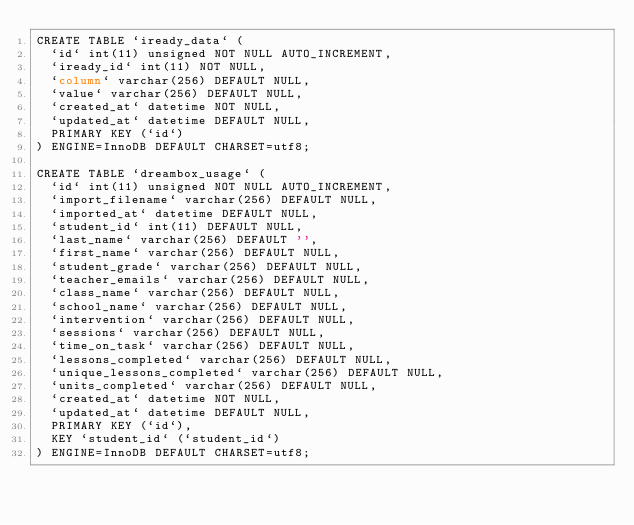Convert code to text. <code><loc_0><loc_0><loc_500><loc_500><_SQL_>CREATE TABLE `iready_data` (
  `id` int(11) unsigned NOT NULL AUTO_INCREMENT,
  `iready_id` int(11) NOT NULL,
  `column` varchar(256) DEFAULT NULL,
  `value` varchar(256) DEFAULT NULL,
  `created_at` datetime NOT NULL,
  `updated_at` datetime DEFAULT NULL,
  PRIMARY KEY (`id`)
) ENGINE=InnoDB DEFAULT CHARSET=utf8;

CREATE TABLE `dreambox_usage` (
  `id` int(11) unsigned NOT NULL AUTO_INCREMENT,
  `import_filename` varchar(256) DEFAULT NULL,
  `imported_at` datetime DEFAULT NULL,
  `student_id` int(11) DEFAULT NULL,
  `last_name` varchar(256) DEFAULT '',
  `first_name` varchar(256) DEFAULT NULL,
  `student_grade` varchar(256) DEFAULT NULL,
  `teacher_emails` varchar(256) DEFAULT NULL,
  `class_name` varchar(256) DEFAULT NULL,
  `school_name` varchar(256) DEFAULT NULL,
  `intervention` varchar(256) DEFAULT NULL,
  `sessions` varchar(256) DEFAULT NULL,
  `time_on_task` varchar(256) DEFAULT NULL,
  `lessons_completed` varchar(256) DEFAULT NULL,
  `unique_lessons_completed` varchar(256) DEFAULT NULL,
  `units_completed` varchar(256) DEFAULT NULL,
  `created_at` datetime NOT NULL,
  `updated_at` datetime DEFAULT NULL,
  PRIMARY KEY (`id`),
  KEY `student_id` (`student_id`)
) ENGINE=InnoDB DEFAULT CHARSET=utf8;</code> 